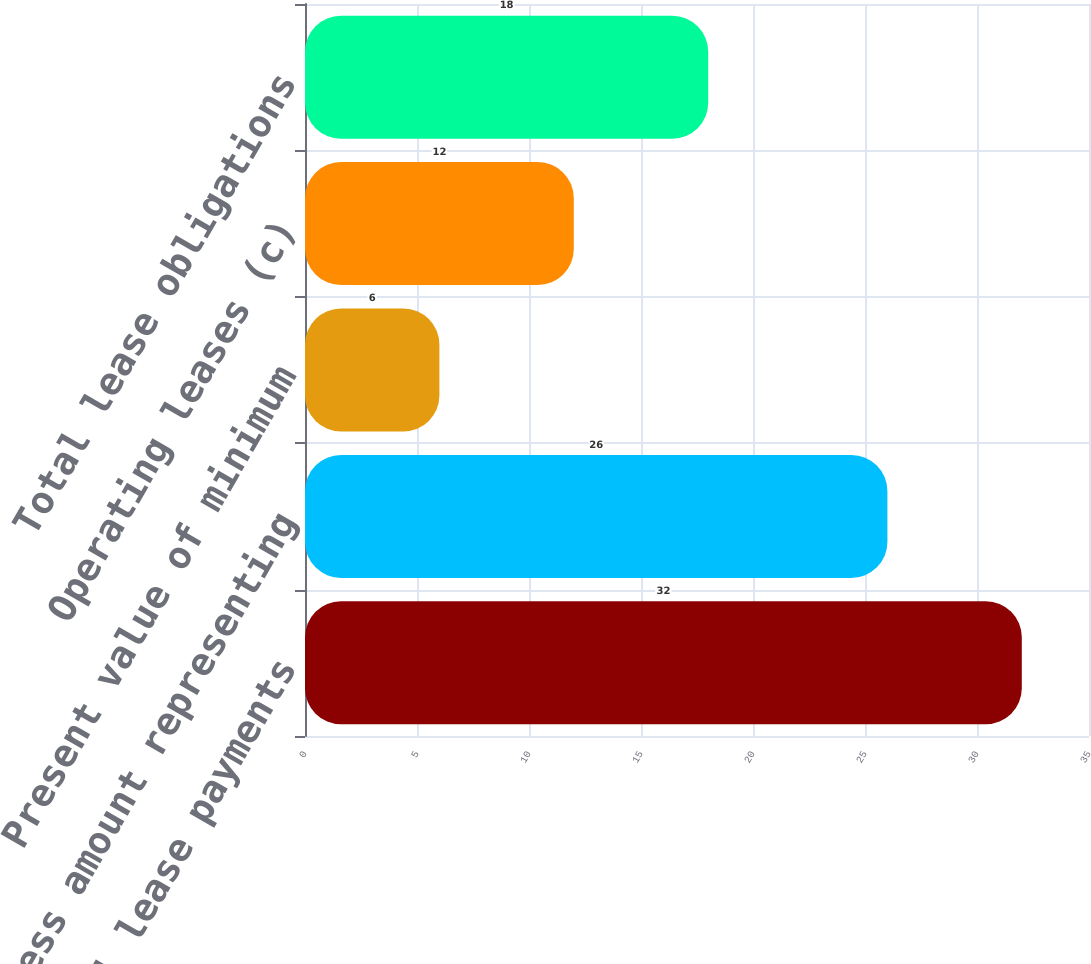Convert chart to OTSL. <chart><loc_0><loc_0><loc_500><loc_500><bar_chart><fcel>Minimum capital lease payments<fcel>Less amount representing<fcel>Present value of minimum<fcel>Operating leases (c)<fcel>Total lease obligations<nl><fcel>32<fcel>26<fcel>6<fcel>12<fcel>18<nl></chart> 